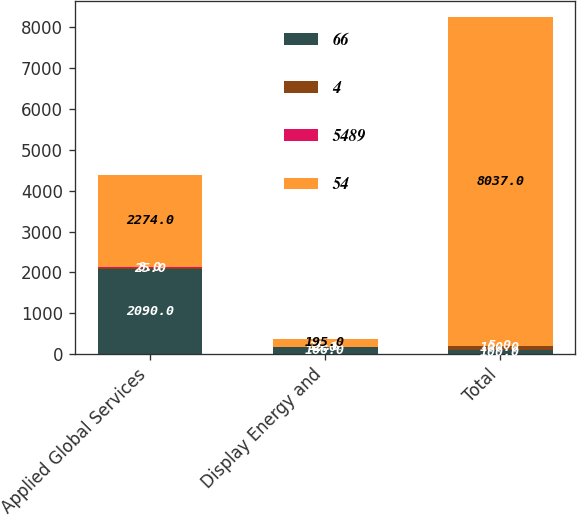Convert chart to OTSL. <chart><loc_0><loc_0><loc_500><loc_500><stacked_bar_chart><ecel><fcel>Applied Global Services<fcel>Display Energy and<fcel>Total<nl><fcel>66<fcel>2090<fcel>166<fcel>100<nl><fcel>4<fcel>25<fcel>2<fcel>100<nl><fcel>5489<fcel>8<fcel>15<fcel>5<nl><fcel>54<fcel>2274<fcel>195<fcel>8037<nl></chart> 